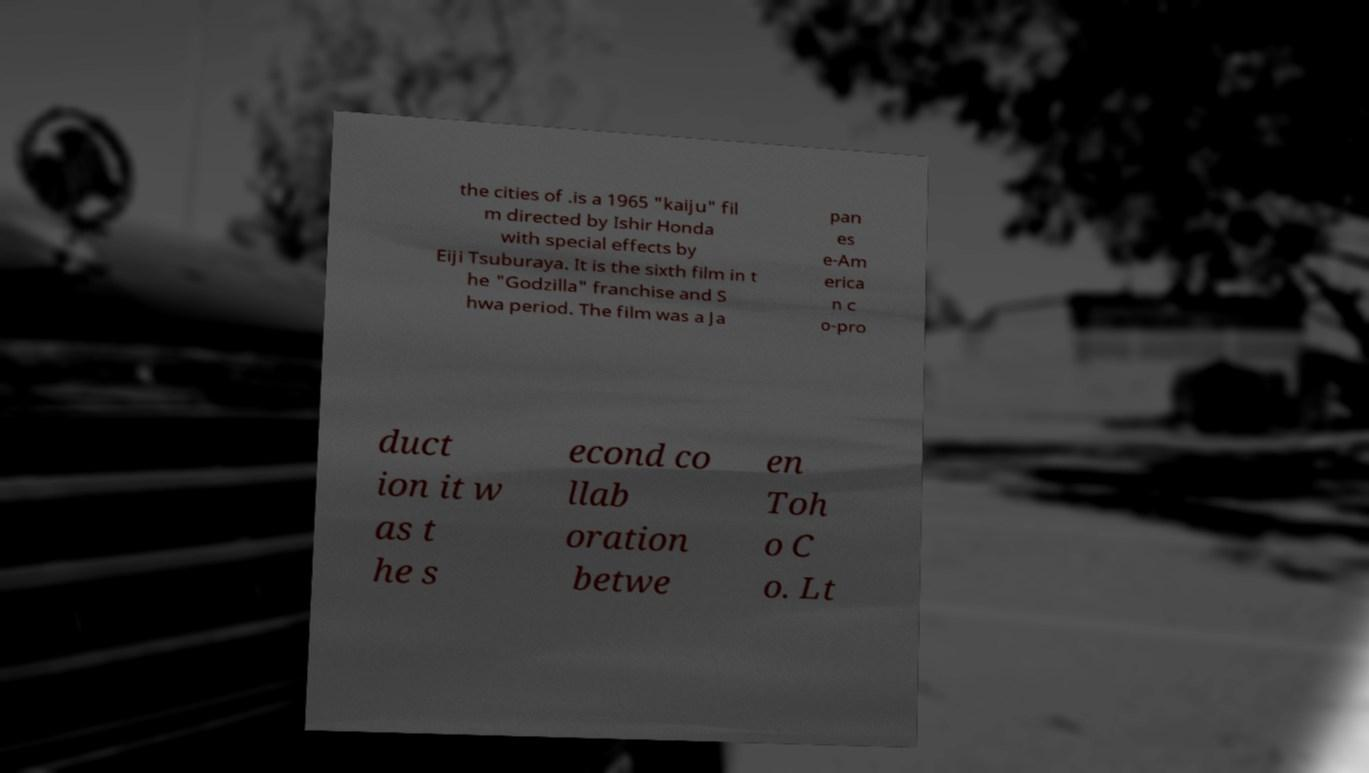I need the written content from this picture converted into text. Can you do that? the cities of .is a 1965 "kaiju" fil m directed by Ishir Honda with special effects by Eiji Tsuburaya. It is the sixth film in t he "Godzilla" franchise and S hwa period. The film was a Ja pan es e-Am erica n c o-pro duct ion it w as t he s econd co llab oration betwe en Toh o C o. Lt 